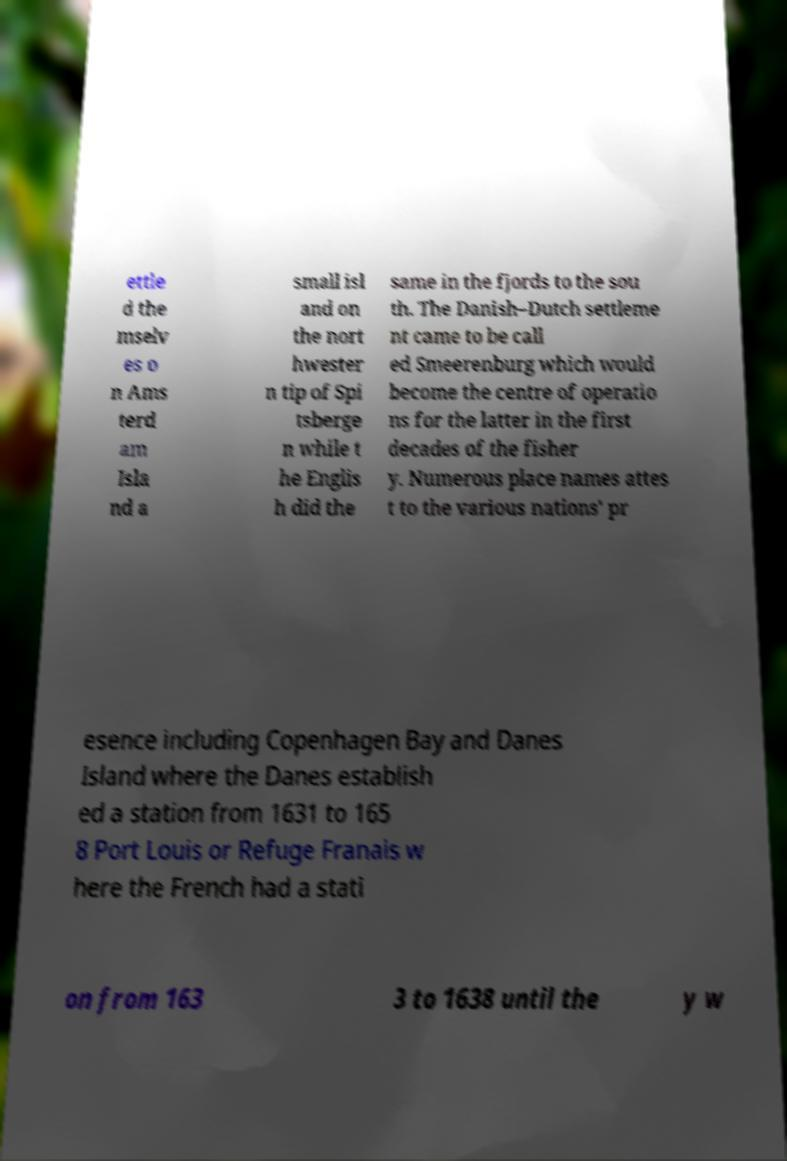I need the written content from this picture converted into text. Can you do that? ettle d the mselv es o n Ams terd am Isla nd a small isl and on the nort hwester n tip of Spi tsberge n while t he Englis h did the same in the fjords to the sou th. The Danish–Dutch settleme nt came to be call ed Smeerenburg which would become the centre of operatio ns for the latter in the first decades of the fisher y. Numerous place names attes t to the various nations' pr esence including Copenhagen Bay and Danes Island where the Danes establish ed a station from 1631 to 165 8 Port Louis or Refuge Franais w here the French had a stati on from 163 3 to 1638 until the y w 